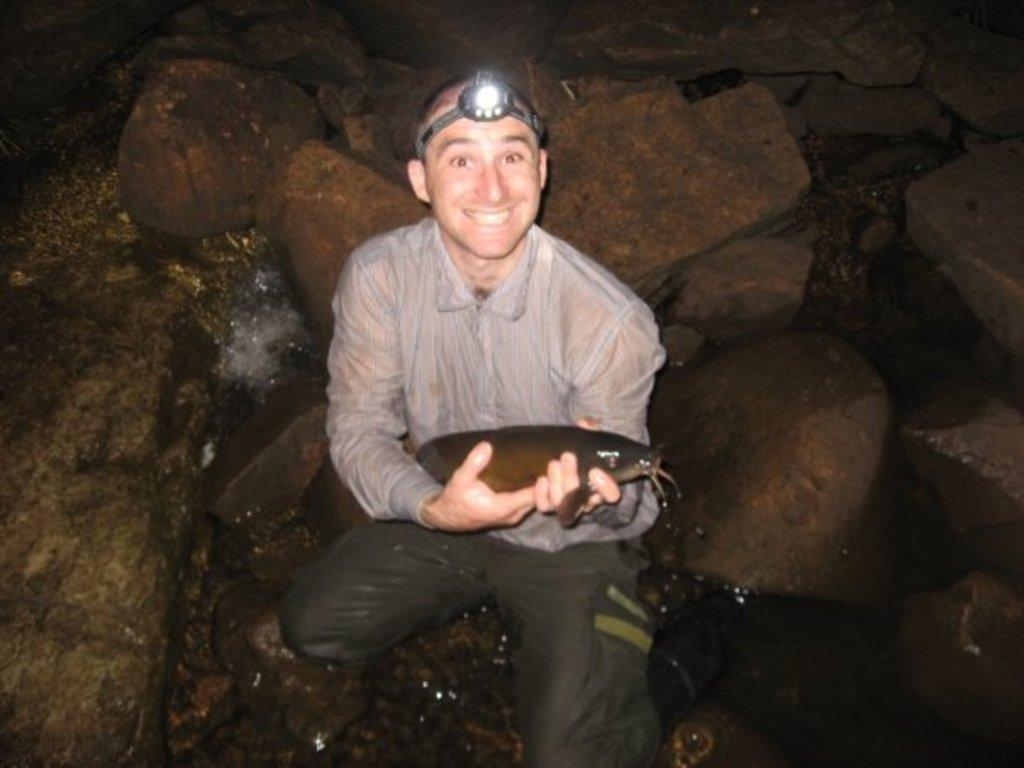What can be seen in the image? There is a person in the image. What is the person holding? The person is holding something, but the facts do not specify what it is. How is the person illuminated in the image? The person is wearing a LED headlight. What type of terrain is visible in the image? There are rocks and water visible in the image. Can you tell me what type of camera the snail is using in the image? There is no snail present in the image, and therefore no camera or photography activity can be observed. 